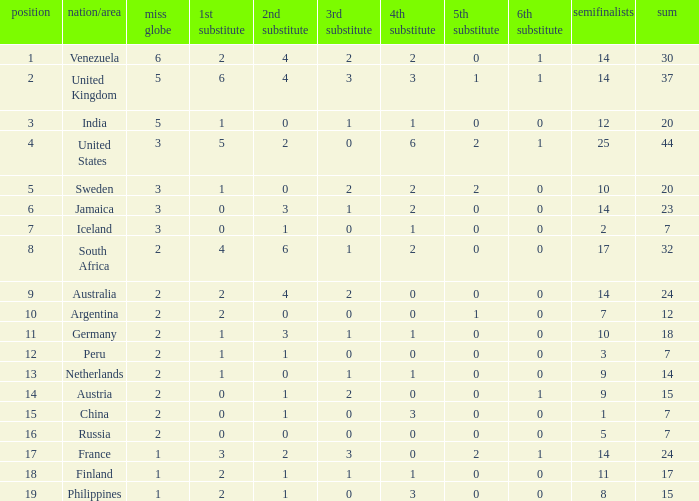Help me parse the entirety of this table. {'header': ['position', 'nation/area', 'miss globe', '1st substitute', '2nd substitute', '3rd substitute', '4th substitute', '5th substitute', '6th substitute', 'semifinalists', 'sum'], 'rows': [['1', 'Venezuela', '6', '2', '4', '2', '2', '0', '1', '14', '30'], ['2', 'United Kingdom', '5', '6', '4', '3', '3', '1', '1', '14', '37'], ['3', 'India', '5', '1', '0', '1', '1', '0', '0', '12', '20'], ['4', 'United States', '3', '5', '2', '0', '6', '2', '1', '25', '44'], ['5', 'Sweden', '3', '1', '0', '2', '2', '2', '0', '10', '20'], ['6', 'Jamaica', '3', '0', '3', '1', '2', '0', '0', '14', '23'], ['7', 'Iceland', '3', '0', '1', '0', '1', '0', '0', '2', '7'], ['8', 'South Africa', '2', '4', '6', '1', '2', '0', '0', '17', '32'], ['9', 'Australia', '2', '2', '4', '2', '0', '0', '0', '14', '24'], ['10', 'Argentina', '2', '2', '0', '0', '0', '1', '0', '7', '12'], ['11', 'Germany', '2', '1', '3', '1', '1', '0', '0', '10', '18'], ['12', 'Peru', '2', '1', '1', '0', '0', '0', '0', '3', '7'], ['13', 'Netherlands', '2', '1', '0', '1', '1', '0', '0', '9', '14'], ['14', 'Austria', '2', '0', '1', '2', '0', '0', '1', '9', '15'], ['15', 'China', '2', '0', '1', '0', '3', '0', '0', '1', '7'], ['16', 'Russia', '2', '0', '0', '0', '0', '0', '0', '5', '7'], ['17', 'France', '1', '3', '2', '3', '0', '2', '1', '14', '24'], ['18', 'Finland', '1', '2', '1', '1', '1', '0', '0', '11', '17'], ['19', 'Philippines', '1', '2', '1', '0', '3', '0', '0', '8', '15']]} What is Iceland's total? 1.0. 